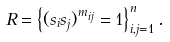<formula> <loc_0><loc_0><loc_500><loc_500>R = \left \{ ( s _ { i } s _ { j } ) ^ { m _ { i j } } = 1 \right \} _ { i , j = 1 } ^ { n } .</formula> 